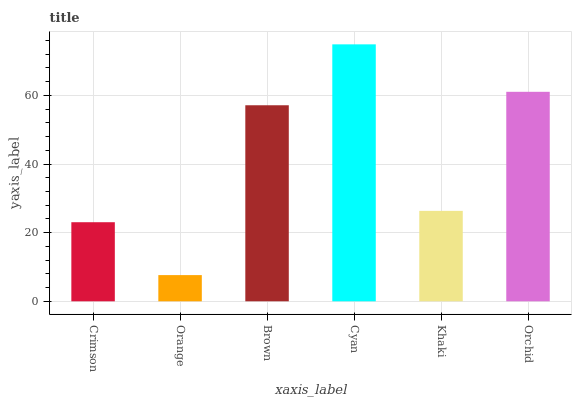Is Orange the minimum?
Answer yes or no. Yes. Is Cyan the maximum?
Answer yes or no. Yes. Is Brown the minimum?
Answer yes or no. No. Is Brown the maximum?
Answer yes or no. No. Is Brown greater than Orange?
Answer yes or no. Yes. Is Orange less than Brown?
Answer yes or no. Yes. Is Orange greater than Brown?
Answer yes or no. No. Is Brown less than Orange?
Answer yes or no. No. Is Brown the high median?
Answer yes or no. Yes. Is Khaki the low median?
Answer yes or no. Yes. Is Orange the high median?
Answer yes or no. No. Is Orange the low median?
Answer yes or no. No. 